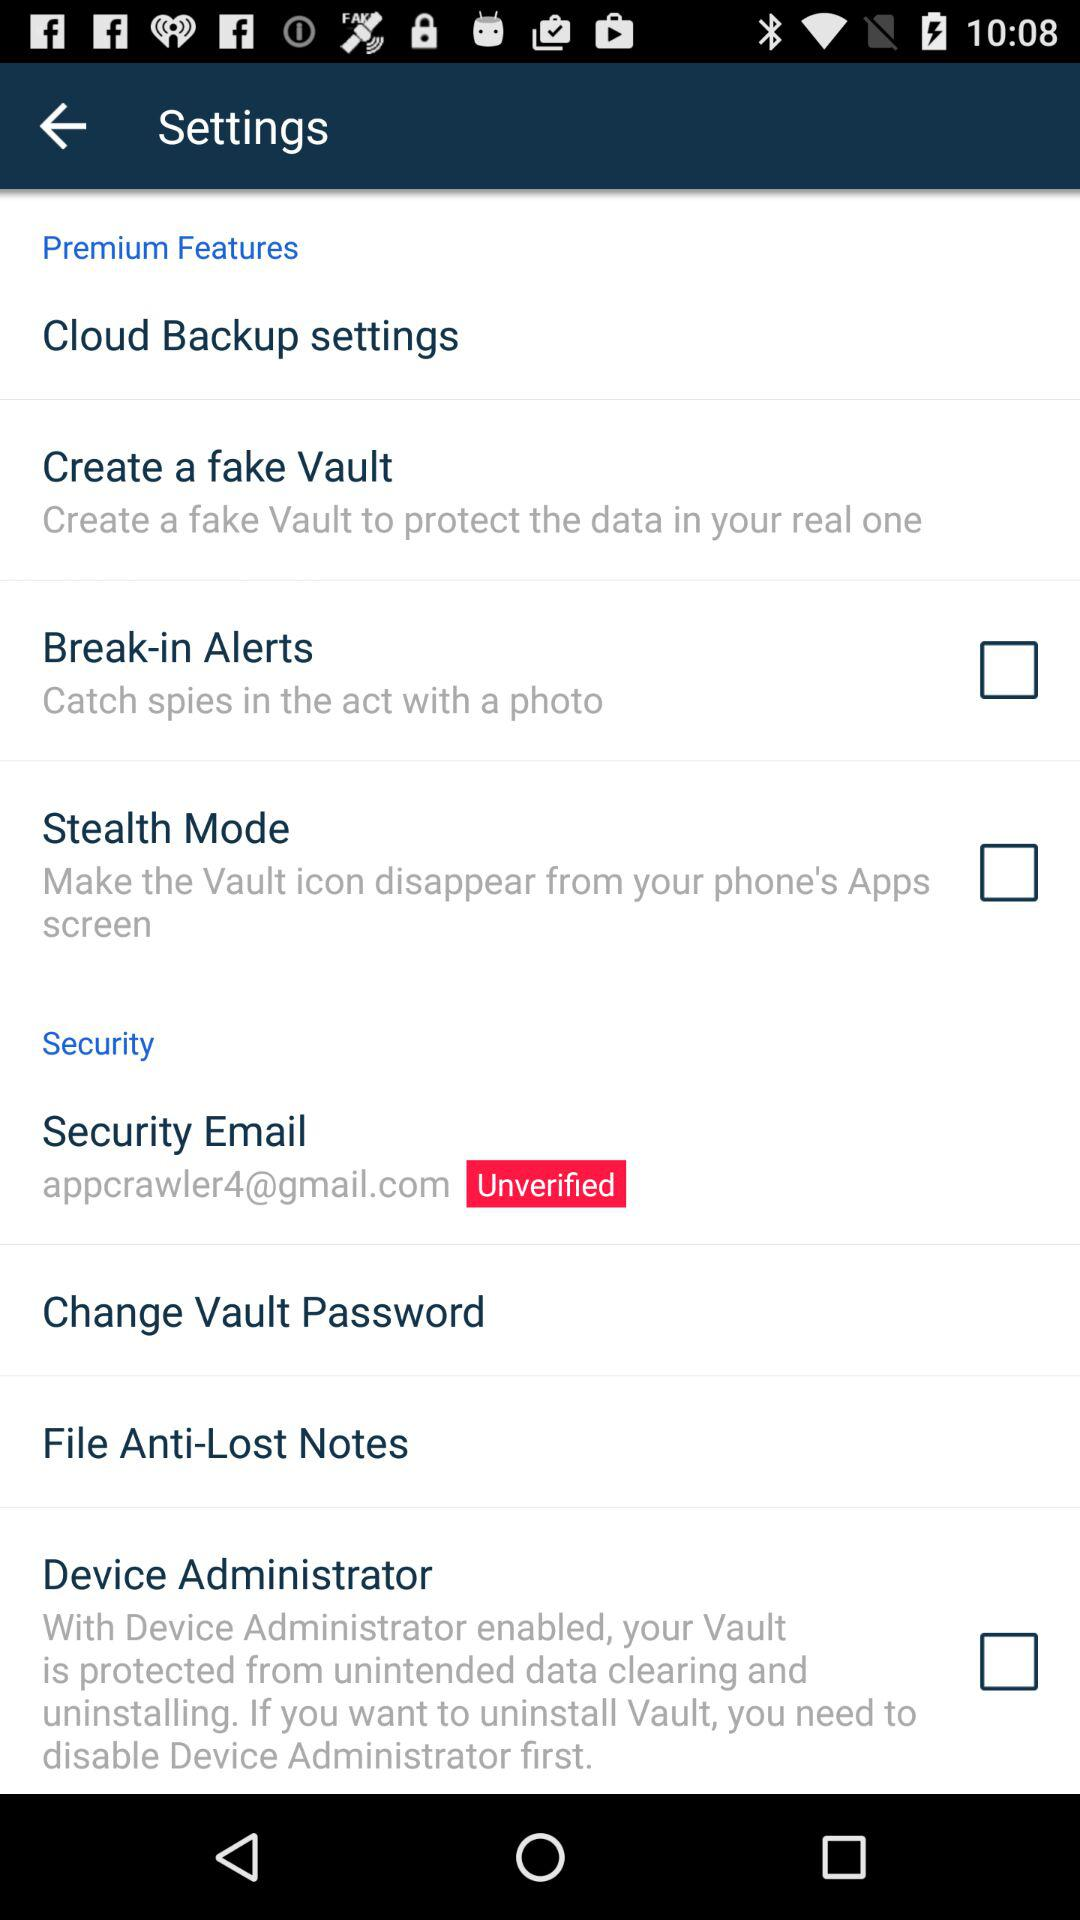What's the status of "Security Email" address? The status of "Security Email" address is "Unverified". 